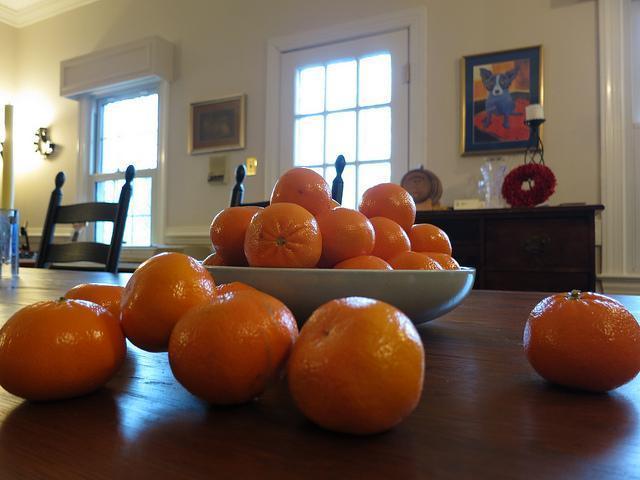How many oranges can you see?
Give a very brief answer. 8. How many cars are waiting at the light?
Give a very brief answer. 0. 